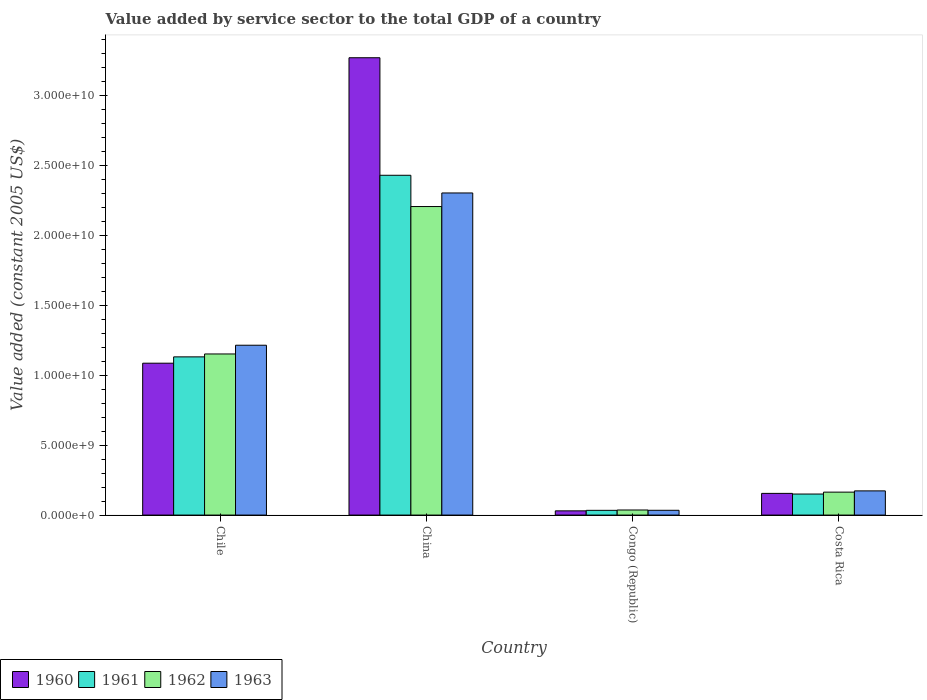Are the number of bars on each tick of the X-axis equal?
Give a very brief answer. Yes. In how many cases, is the number of bars for a given country not equal to the number of legend labels?
Offer a very short reply. 0. What is the value added by service sector in 1962 in China?
Your response must be concise. 2.21e+1. Across all countries, what is the maximum value added by service sector in 1962?
Give a very brief answer. 2.21e+1. Across all countries, what is the minimum value added by service sector in 1960?
Ensure brevity in your answer.  3.02e+08. In which country was the value added by service sector in 1962 maximum?
Your response must be concise. China. In which country was the value added by service sector in 1961 minimum?
Offer a very short reply. Congo (Republic). What is the total value added by service sector in 1963 in the graph?
Provide a succinct answer. 3.73e+1. What is the difference between the value added by service sector in 1962 in Congo (Republic) and that in Costa Rica?
Your answer should be very brief. -1.28e+09. What is the difference between the value added by service sector in 1961 in Chile and the value added by service sector in 1962 in Congo (Republic)?
Your answer should be compact. 1.10e+1. What is the average value added by service sector in 1960 per country?
Your response must be concise. 1.14e+1. What is the difference between the value added by service sector of/in 1963 and value added by service sector of/in 1961 in Congo (Republic)?
Ensure brevity in your answer.  3.09e+06. What is the ratio of the value added by service sector in 1961 in Chile to that in Congo (Republic)?
Give a very brief answer. 33.4. What is the difference between the highest and the second highest value added by service sector in 1960?
Offer a terse response. 9.31e+09. What is the difference between the highest and the lowest value added by service sector in 1961?
Keep it short and to the point. 2.40e+1. In how many countries, is the value added by service sector in 1960 greater than the average value added by service sector in 1960 taken over all countries?
Keep it short and to the point. 1. Is the sum of the value added by service sector in 1963 in China and Congo (Republic) greater than the maximum value added by service sector in 1962 across all countries?
Your response must be concise. Yes. Is it the case that in every country, the sum of the value added by service sector in 1962 and value added by service sector in 1960 is greater than the sum of value added by service sector in 1963 and value added by service sector in 1961?
Offer a very short reply. No. What does the 1st bar from the left in Costa Rica represents?
Your answer should be compact. 1960. What does the 2nd bar from the right in Chile represents?
Make the answer very short. 1962. How many bars are there?
Keep it short and to the point. 16. Are all the bars in the graph horizontal?
Make the answer very short. No. How many countries are there in the graph?
Offer a terse response. 4. Are the values on the major ticks of Y-axis written in scientific E-notation?
Your response must be concise. Yes. Where does the legend appear in the graph?
Your response must be concise. Bottom left. What is the title of the graph?
Your answer should be compact. Value added by service sector to the total GDP of a country. What is the label or title of the X-axis?
Offer a terse response. Country. What is the label or title of the Y-axis?
Ensure brevity in your answer.  Value added (constant 2005 US$). What is the Value added (constant 2005 US$) of 1960 in Chile?
Ensure brevity in your answer.  1.09e+1. What is the Value added (constant 2005 US$) of 1961 in Chile?
Your response must be concise. 1.13e+1. What is the Value added (constant 2005 US$) of 1962 in Chile?
Ensure brevity in your answer.  1.15e+1. What is the Value added (constant 2005 US$) of 1963 in Chile?
Your response must be concise. 1.22e+1. What is the Value added (constant 2005 US$) in 1960 in China?
Ensure brevity in your answer.  3.27e+1. What is the Value added (constant 2005 US$) in 1961 in China?
Your response must be concise. 2.43e+1. What is the Value added (constant 2005 US$) of 1962 in China?
Make the answer very short. 2.21e+1. What is the Value added (constant 2005 US$) of 1963 in China?
Your response must be concise. 2.30e+1. What is the Value added (constant 2005 US$) of 1960 in Congo (Republic)?
Make the answer very short. 3.02e+08. What is the Value added (constant 2005 US$) in 1961 in Congo (Republic)?
Provide a succinct answer. 3.39e+08. What is the Value added (constant 2005 US$) in 1962 in Congo (Republic)?
Your answer should be compact. 3.64e+08. What is the Value added (constant 2005 US$) of 1963 in Congo (Republic)?
Offer a very short reply. 3.42e+08. What is the Value added (constant 2005 US$) in 1960 in Costa Rica?
Ensure brevity in your answer.  1.55e+09. What is the Value added (constant 2005 US$) of 1961 in Costa Rica?
Provide a succinct answer. 1.51e+09. What is the Value added (constant 2005 US$) of 1962 in Costa Rica?
Your answer should be compact. 1.64e+09. What is the Value added (constant 2005 US$) in 1963 in Costa Rica?
Your answer should be very brief. 1.73e+09. Across all countries, what is the maximum Value added (constant 2005 US$) of 1960?
Your answer should be compact. 3.27e+1. Across all countries, what is the maximum Value added (constant 2005 US$) in 1961?
Offer a terse response. 2.43e+1. Across all countries, what is the maximum Value added (constant 2005 US$) of 1962?
Keep it short and to the point. 2.21e+1. Across all countries, what is the maximum Value added (constant 2005 US$) of 1963?
Your answer should be compact. 2.30e+1. Across all countries, what is the minimum Value added (constant 2005 US$) in 1960?
Make the answer very short. 3.02e+08. Across all countries, what is the minimum Value added (constant 2005 US$) of 1961?
Keep it short and to the point. 3.39e+08. Across all countries, what is the minimum Value added (constant 2005 US$) of 1962?
Your answer should be compact. 3.64e+08. Across all countries, what is the minimum Value added (constant 2005 US$) in 1963?
Give a very brief answer. 3.42e+08. What is the total Value added (constant 2005 US$) of 1960 in the graph?
Make the answer very short. 4.54e+1. What is the total Value added (constant 2005 US$) in 1961 in the graph?
Keep it short and to the point. 3.75e+1. What is the total Value added (constant 2005 US$) in 1962 in the graph?
Provide a succinct answer. 3.56e+1. What is the total Value added (constant 2005 US$) in 1963 in the graph?
Your answer should be compact. 3.73e+1. What is the difference between the Value added (constant 2005 US$) in 1960 in Chile and that in China?
Provide a succinct answer. -2.19e+1. What is the difference between the Value added (constant 2005 US$) of 1961 in Chile and that in China?
Offer a terse response. -1.30e+1. What is the difference between the Value added (constant 2005 US$) of 1962 in Chile and that in China?
Provide a succinct answer. -1.05e+1. What is the difference between the Value added (constant 2005 US$) in 1963 in Chile and that in China?
Your answer should be very brief. -1.09e+1. What is the difference between the Value added (constant 2005 US$) in 1960 in Chile and that in Congo (Republic)?
Your answer should be compact. 1.06e+1. What is the difference between the Value added (constant 2005 US$) in 1961 in Chile and that in Congo (Republic)?
Your answer should be compact. 1.10e+1. What is the difference between the Value added (constant 2005 US$) in 1962 in Chile and that in Congo (Republic)?
Give a very brief answer. 1.12e+1. What is the difference between the Value added (constant 2005 US$) in 1963 in Chile and that in Congo (Republic)?
Offer a terse response. 1.18e+1. What is the difference between the Value added (constant 2005 US$) in 1960 in Chile and that in Costa Rica?
Keep it short and to the point. 9.31e+09. What is the difference between the Value added (constant 2005 US$) of 1961 in Chile and that in Costa Rica?
Offer a terse response. 9.81e+09. What is the difference between the Value added (constant 2005 US$) in 1962 in Chile and that in Costa Rica?
Give a very brief answer. 9.89e+09. What is the difference between the Value added (constant 2005 US$) of 1963 in Chile and that in Costa Rica?
Your response must be concise. 1.04e+1. What is the difference between the Value added (constant 2005 US$) in 1960 in China and that in Congo (Republic)?
Make the answer very short. 3.24e+1. What is the difference between the Value added (constant 2005 US$) of 1961 in China and that in Congo (Republic)?
Give a very brief answer. 2.40e+1. What is the difference between the Value added (constant 2005 US$) in 1962 in China and that in Congo (Republic)?
Your answer should be compact. 2.17e+1. What is the difference between the Value added (constant 2005 US$) of 1963 in China and that in Congo (Republic)?
Give a very brief answer. 2.27e+1. What is the difference between the Value added (constant 2005 US$) of 1960 in China and that in Costa Rica?
Provide a short and direct response. 3.12e+1. What is the difference between the Value added (constant 2005 US$) in 1961 in China and that in Costa Rica?
Offer a terse response. 2.28e+1. What is the difference between the Value added (constant 2005 US$) of 1962 in China and that in Costa Rica?
Provide a succinct answer. 2.04e+1. What is the difference between the Value added (constant 2005 US$) in 1963 in China and that in Costa Rica?
Ensure brevity in your answer.  2.13e+1. What is the difference between the Value added (constant 2005 US$) of 1960 in Congo (Republic) and that in Costa Rica?
Keep it short and to the point. -1.25e+09. What is the difference between the Value added (constant 2005 US$) in 1961 in Congo (Republic) and that in Costa Rica?
Your answer should be very brief. -1.17e+09. What is the difference between the Value added (constant 2005 US$) of 1962 in Congo (Republic) and that in Costa Rica?
Ensure brevity in your answer.  -1.28e+09. What is the difference between the Value added (constant 2005 US$) of 1963 in Congo (Republic) and that in Costa Rica?
Provide a succinct answer. -1.39e+09. What is the difference between the Value added (constant 2005 US$) of 1960 in Chile and the Value added (constant 2005 US$) of 1961 in China?
Provide a succinct answer. -1.34e+1. What is the difference between the Value added (constant 2005 US$) in 1960 in Chile and the Value added (constant 2005 US$) in 1962 in China?
Your response must be concise. -1.12e+1. What is the difference between the Value added (constant 2005 US$) in 1960 in Chile and the Value added (constant 2005 US$) in 1963 in China?
Give a very brief answer. -1.22e+1. What is the difference between the Value added (constant 2005 US$) in 1961 in Chile and the Value added (constant 2005 US$) in 1962 in China?
Provide a short and direct response. -1.08e+1. What is the difference between the Value added (constant 2005 US$) of 1961 in Chile and the Value added (constant 2005 US$) of 1963 in China?
Offer a terse response. -1.17e+1. What is the difference between the Value added (constant 2005 US$) of 1962 in Chile and the Value added (constant 2005 US$) of 1963 in China?
Offer a terse response. -1.15e+1. What is the difference between the Value added (constant 2005 US$) of 1960 in Chile and the Value added (constant 2005 US$) of 1961 in Congo (Republic)?
Ensure brevity in your answer.  1.05e+1. What is the difference between the Value added (constant 2005 US$) in 1960 in Chile and the Value added (constant 2005 US$) in 1962 in Congo (Republic)?
Give a very brief answer. 1.05e+1. What is the difference between the Value added (constant 2005 US$) of 1960 in Chile and the Value added (constant 2005 US$) of 1963 in Congo (Republic)?
Offer a very short reply. 1.05e+1. What is the difference between the Value added (constant 2005 US$) of 1961 in Chile and the Value added (constant 2005 US$) of 1962 in Congo (Republic)?
Provide a succinct answer. 1.10e+1. What is the difference between the Value added (constant 2005 US$) in 1961 in Chile and the Value added (constant 2005 US$) in 1963 in Congo (Republic)?
Offer a terse response. 1.10e+1. What is the difference between the Value added (constant 2005 US$) of 1962 in Chile and the Value added (constant 2005 US$) of 1963 in Congo (Republic)?
Your response must be concise. 1.12e+1. What is the difference between the Value added (constant 2005 US$) in 1960 in Chile and the Value added (constant 2005 US$) in 1961 in Costa Rica?
Provide a succinct answer. 9.36e+09. What is the difference between the Value added (constant 2005 US$) of 1960 in Chile and the Value added (constant 2005 US$) of 1962 in Costa Rica?
Offer a very short reply. 9.23e+09. What is the difference between the Value added (constant 2005 US$) of 1960 in Chile and the Value added (constant 2005 US$) of 1963 in Costa Rica?
Offer a very short reply. 9.14e+09. What is the difference between the Value added (constant 2005 US$) of 1961 in Chile and the Value added (constant 2005 US$) of 1962 in Costa Rica?
Offer a terse response. 9.68e+09. What is the difference between the Value added (constant 2005 US$) in 1961 in Chile and the Value added (constant 2005 US$) in 1963 in Costa Rica?
Give a very brief answer. 9.59e+09. What is the difference between the Value added (constant 2005 US$) in 1962 in Chile and the Value added (constant 2005 US$) in 1963 in Costa Rica?
Provide a succinct answer. 9.80e+09. What is the difference between the Value added (constant 2005 US$) in 1960 in China and the Value added (constant 2005 US$) in 1961 in Congo (Republic)?
Provide a short and direct response. 3.24e+1. What is the difference between the Value added (constant 2005 US$) of 1960 in China and the Value added (constant 2005 US$) of 1962 in Congo (Republic)?
Your answer should be very brief. 3.24e+1. What is the difference between the Value added (constant 2005 US$) in 1960 in China and the Value added (constant 2005 US$) in 1963 in Congo (Republic)?
Keep it short and to the point. 3.24e+1. What is the difference between the Value added (constant 2005 US$) of 1961 in China and the Value added (constant 2005 US$) of 1962 in Congo (Republic)?
Ensure brevity in your answer.  2.39e+1. What is the difference between the Value added (constant 2005 US$) of 1961 in China and the Value added (constant 2005 US$) of 1963 in Congo (Republic)?
Your answer should be very brief. 2.40e+1. What is the difference between the Value added (constant 2005 US$) of 1962 in China and the Value added (constant 2005 US$) of 1963 in Congo (Republic)?
Your answer should be very brief. 2.17e+1. What is the difference between the Value added (constant 2005 US$) of 1960 in China and the Value added (constant 2005 US$) of 1961 in Costa Rica?
Offer a very short reply. 3.12e+1. What is the difference between the Value added (constant 2005 US$) of 1960 in China and the Value added (constant 2005 US$) of 1962 in Costa Rica?
Provide a succinct answer. 3.11e+1. What is the difference between the Value added (constant 2005 US$) of 1960 in China and the Value added (constant 2005 US$) of 1963 in Costa Rica?
Offer a terse response. 3.10e+1. What is the difference between the Value added (constant 2005 US$) in 1961 in China and the Value added (constant 2005 US$) in 1962 in Costa Rica?
Your answer should be very brief. 2.27e+1. What is the difference between the Value added (constant 2005 US$) of 1961 in China and the Value added (constant 2005 US$) of 1963 in Costa Rica?
Provide a short and direct response. 2.26e+1. What is the difference between the Value added (constant 2005 US$) in 1962 in China and the Value added (constant 2005 US$) in 1963 in Costa Rica?
Make the answer very short. 2.03e+1. What is the difference between the Value added (constant 2005 US$) of 1960 in Congo (Republic) and the Value added (constant 2005 US$) of 1961 in Costa Rica?
Give a very brief answer. -1.20e+09. What is the difference between the Value added (constant 2005 US$) of 1960 in Congo (Republic) and the Value added (constant 2005 US$) of 1962 in Costa Rica?
Give a very brief answer. -1.34e+09. What is the difference between the Value added (constant 2005 US$) of 1960 in Congo (Republic) and the Value added (constant 2005 US$) of 1963 in Costa Rica?
Your answer should be compact. -1.43e+09. What is the difference between the Value added (constant 2005 US$) of 1961 in Congo (Republic) and the Value added (constant 2005 US$) of 1962 in Costa Rica?
Your response must be concise. -1.30e+09. What is the difference between the Value added (constant 2005 US$) in 1961 in Congo (Republic) and the Value added (constant 2005 US$) in 1963 in Costa Rica?
Your answer should be compact. -1.39e+09. What is the difference between the Value added (constant 2005 US$) of 1962 in Congo (Republic) and the Value added (constant 2005 US$) of 1963 in Costa Rica?
Your answer should be compact. -1.37e+09. What is the average Value added (constant 2005 US$) of 1960 per country?
Give a very brief answer. 1.14e+1. What is the average Value added (constant 2005 US$) in 1961 per country?
Your response must be concise. 9.37e+09. What is the average Value added (constant 2005 US$) of 1962 per country?
Offer a terse response. 8.90e+09. What is the average Value added (constant 2005 US$) of 1963 per country?
Provide a succinct answer. 9.32e+09. What is the difference between the Value added (constant 2005 US$) of 1960 and Value added (constant 2005 US$) of 1961 in Chile?
Provide a succinct answer. -4.53e+08. What is the difference between the Value added (constant 2005 US$) in 1960 and Value added (constant 2005 US$) in 1962 in Chile?
Your answer should be compact. -6.60e+08. What is the difference between the Value added (constant 2005 US$) in 1960 and Value added (constant 2005 US$) in 1963 in Chile?
Give a very brief answer. -1.29e+09. What is the difference between the Value added (constant 2005 US$) in 1961 and Value added (constant 2005 US$) in 1962 in Chile?
Ensure brevity in your answer.  -2.07e+08. What is the difference between the Value added (constant 2005 US$) in 1961 and Value added (constant 2005 US$) in 1963 in Chile?
Offer a terse response. -8.32e+08. What is the difference between the Value added (constant 2005 US$) of 1962 and Value added (constant 2005 US$) of 1963 in Chile?
Offer a terse response. -6.25e+08. What is the difference between the Value added (constant 2005 US$) in 1960 and Value added (constant 2005 US$) in 1961 in China?
Your answer should be very brief. 8.41e+09. What is the difference between the Value added (constant 2005 US$) of 1960 and Value added (constant 2005 US$) of 1962 in China?
Ensure brevity in your answer.  1.06e+1. What is the difference between the Value added (constant 2005 US$) of 1960 and Value added (constant 2005 US$) of 1963 in China?
Ensure brevity in your answer.  9.68e+09. What is the difference between the Value added (constant 2005 US$) in 1961 and Value added (constant 2005 US$) in 1962 in China?
Your answer should be very brief. 2.24e+09. What is the difference between the Value added (constant 2005 US$) in 1961 and Value added (constant 2005 US$) in 1963 in China?
Offer a very short reply. 1.27e+09. What is the difference between the Value added (constant 2005 US$) in 1962 and Value added (constant 2005 US$) in 1963 in China?
Your response must be concise. -9.71e+08. What is the difference between the Value added (constant 2005 US$) of 1960 and Value added (constant 2005 US$) of 1961 in Congo (Republic)?
Your response must be concise. -3.74e+07. What is the difference between the Value added (constant 2005 US$) in 1960 and Value added (constant 2005 US$) in 1962 in Congo (Republic)?
Make the answer very short. -6.23e+07. What is the difference between the Value added (constant 2005 US$) in 1960 and Value added (constant 2005 US$) in 1963 in Congo (Republic)?
Provide a short and direct response. -4.05e+07. What is the difference between the Value added (constant 2005 US$) in 1961 and Value added (constant 2005 US$) in 1962 in Congo (Republic)?
Give a very brief answer. -2.49e+07. What is the difference between the Value added (constant 2005 US$) in 1961 and Value added (constant 2005 US$) in 1963 in Congo (Republic)?
Offer a terse response. -3.09e+06. What is the difference between the Value added (constant 2005 US$) in 1962 and Value added (constant 2005 US$) in 1963 in Congo (Republic)?
Your answer should be compact. 2.18e+07. What is the difference between the Value added (constant 2005 US$) in 1960 and Value added (constant 2005 US$) in 1961 in Costa Rica?
Your answer should be compact. 4.72e+07. What is the difference between the Value added (constant 2005 US$) of 1960 and Value added (constant 2005 US$) of 1962 in Costa Rica?
Make the answer very short. -8.87e+07. What is the difference between the Value added (constant 2005 US$) in 1960 and Value added (constant 2005 US$) in 1963 in Costa Rica?
Keep it short and to the point. -1.78e+08. What is the difference between the Value added (constant 2005 US$) of 1961 and Value added (constant 2005 US$) of 1962 in Costa Rica?
Your answer should be compact. -1.36e+08. What is the difference between the Value added (constant 2005 US$) in 1961 and Value added (constant 2005 US$) in 1963 in Costa Rica?
Give a very brief answer. -2.25e+08. What is the difference between the Value added (constant 2005 US$) of 1962 and Value added (constant 2005 US$) of 1963 in Costa Rica?
Ensure brevity in your answer.  -8.94e+07. What is the ratio of the Value added (constant 2005 US$) in 1960 in Chile to that in China?
Offer a very short reply. 0.33. What is the ratio of the Value added (constant 2005 US$) in 1961 in Chile to that in China?
Offer a very short reply. 0.47. What is the ratio of the Value added (constant 2005 US$) of 1962 in Chile to that in China?
Offer a terse response. 0.52. What is the ratio of the Value added (constant 2005 US$) in 1963 in Chile to that in China?
Offer a very short reply. 0.53. What is the ratio of the Value added (constant 2005 US$) in 1960 in Chile to that in Congo (Republic)?
Your response must be concise. 36.04. What is the ratio of the Value added (constant 2005 US$) in 1961 in Chile to that in Congo (Republic)?
Your response must be concise. 33.4. What is the ratio of the Value added (constant 2005 US$) in 1962 in Chile to that in Congo (Republic)?
Provide a short and direct response. 31.68. What is the ratio of the Value added (constant 2005 US$) of 1963 in Chile to that in Congo (Republic)?
Offer a terse response. 35.53. What is the ratio of the Value added (constant 2005 US$) in 1960 in Chile to that in Costa Rica?
Offer a terse response. 7. What is the ratio of the Value added (constant 2005 US$) in 1961 in Chile to that in Costa Rica?
Ensure brevity in your answer.  7.52. What is the ratio of the Value added (constant 2005 US$) in 1962 in Chile to that in Costa Rica?
Your response must be concise. 7.02. What is the ratio of the Value added (constant 2005 US$) of 1963 in Chile to that in Costa Rica?
Keep it short and to the point. 7.02. What is the ratio of the Value added (constant 2005 US$) in 1960 in China to that in Congo (Republic)?
Your answer should be very brief. 108.51. What is the ratio of the Value added (constant 2005 US$) in 1961 in China to that in Congo (Republic)?
Ensure brevity in your answer.  71.73. What is the ratio of the Value added (constant 2005 US$) of 1962 in China to that in Congo (Republic)?
Give a very brief answer. 60.67. What is the ratio of the Value added (constant 2005 US$) in 1963 in China to that in Congo (Republic)?
Offer a very short reply. 67.39. What is the ratio of the Value added (constant 2005 US$) of 1960 in China to that in Costa Rica?
Keep it short and to the point. 21.08. What is the ratio of the Value added (constant 2005 US$) of 1961 in China to that in Costa Rica?
Your answer should be compact. 16.15. What is the ratio of the Value added (constant 2005 US$) of 1962 in China to that in Costa Rica?
Offer a terse response. 13.45. What is the ratio of the Value added (constant 2005 US$) in 1963 in China to that in Costa Rica?
Your answer should be very brief. 13.32. What is the ratio of the Value added (constant 2005 US$) in 1960 in Congo (Republic) to that in Costa Rica?
Keep it short and to the point. 0.19. What is the ratio of the Value added (constant 2005 US$) of 1961 in Congo (Republic) to that in Costa Rica?
Make the answer very short. 0.23. What is the ratio of the Value added (constant 2005 US$) of 1962 in Congo (Republic) to that in Costa Rica?
Provide a succinct answer. 0.22. What is the ratio of the Value added (constant 2005 US$) of 1963 in Congo (Republic) to that in Costa Rica?
Give a very brief answer. 0.2. What is the difference between the highest and the second highest Value added (constant 2005 US$) in 1960?
Provide a succinct answer. 2.19e+1. What is the difference between the highest and the second highest Value added (constant 2005 US$) in 1961?
Offer a terse response. 1.30e+1. What is the difference between the highest and the second highest Value added (constant 2005 US$) in 1962?
Your answer should be compact. 1.05e+1. What is the difference between the highest and the second highest Value added (constant 2005 US$) of 1963?
Your answer should be compact. 1.09e+1. What is the difference between the highest and the lowest Value added (constant 2005 US$) of 1960?
Provide a short and direct response. 3.24e+1. What is the difference between the highest and the lowest Value added (constant 2005 US$) in 1961?
Offer a very short reply. 2.40e+1. What is the difference between the highest and the lowest Value added (constant 2005 US$) of 1962?
Ensure brevity in your answer.  2.17e+1. What is the difference between the highest and the lowest Value added (constant 2005 US$) in 1963?
Give a very brief answer. 2.27e+1. 